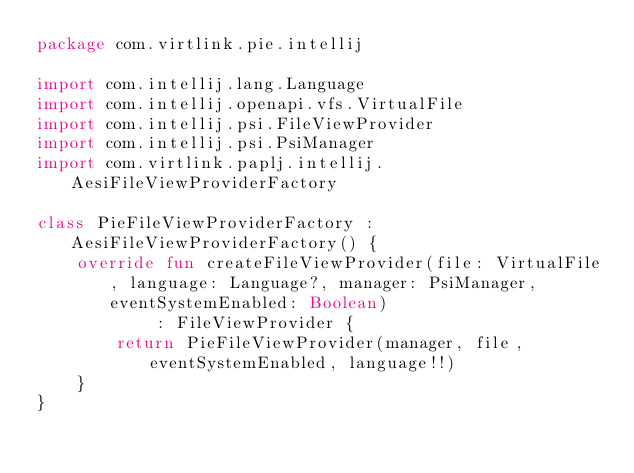<code> <loc_0><loc_0><loc_500><loc_500><_Kotlin_>package com.virtlink.pie.intellij

import com.intellij.lang.Language
import com.intellij.openapi.vfs.VirtualFile
import com.intellij.psi.FileViewProvider
import com.intellij.psi.PsiManager
import com.virtlink.paplj.intellij.AesiFileViewProviderFactory

class PieFileViewProviderFactory : AesiFileViewProviderFactory() {
    override fun createFileViewProvider(file: VirtualFile, language: Language?, manager: PsiManager, eventSystemEnabled: Boolean)
            : FileViewProvider {
        return PieFileViewProvider(manager, file, eventSystemEnabled, language!!)
    }
}</code> 